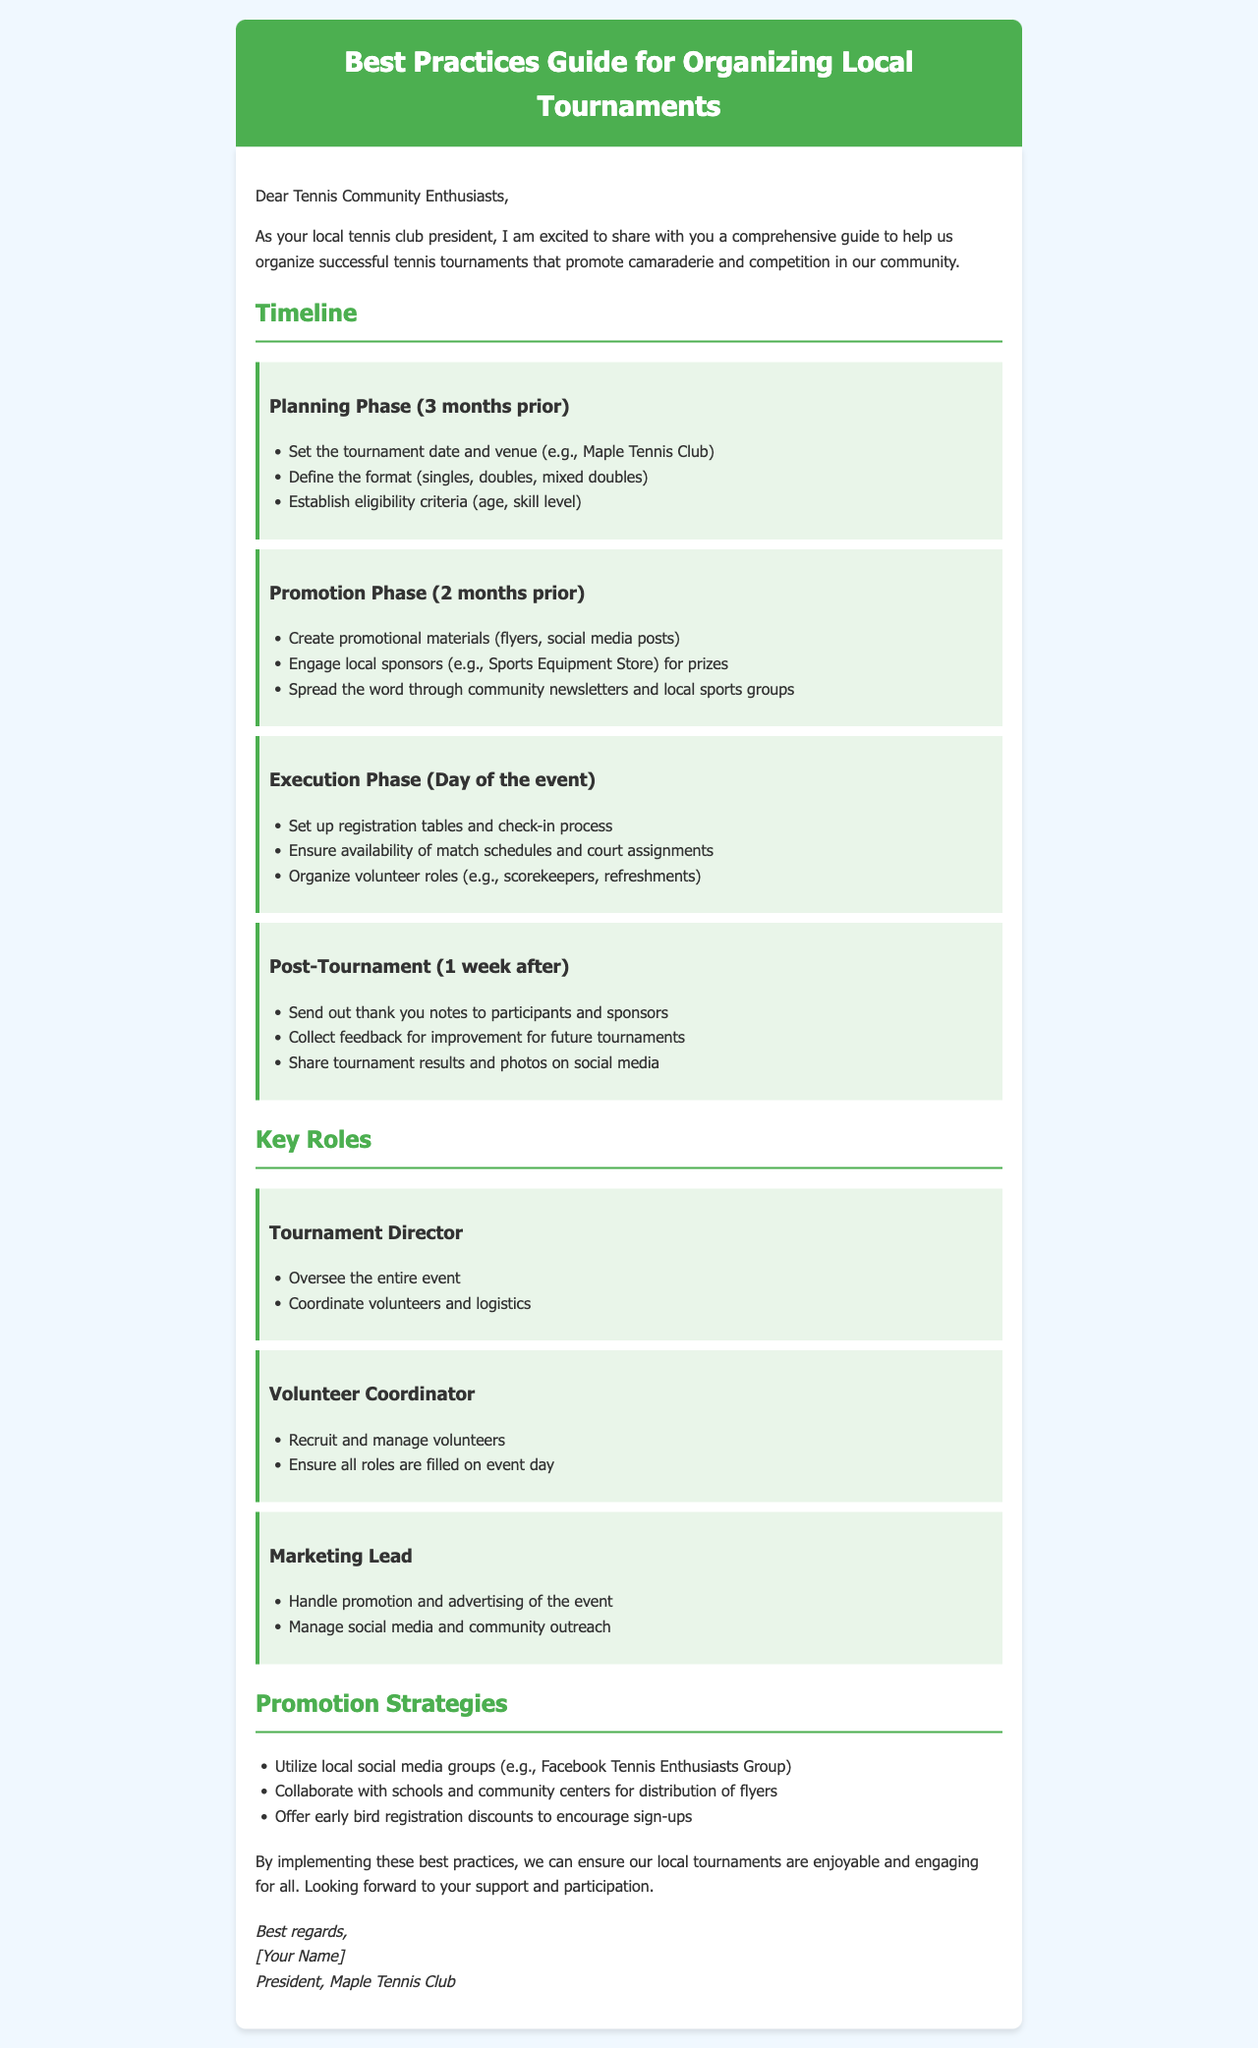What is the planning phase time frame? The planning phase occurs three months prior to the tournament.
Answer: 3 months prior What is one key role of the Marketing Lead? The Marketing Lead is responsible for handling promotion and advertising of the event.
Answer: Handle promotion What is one promotion strategy mentioned? A promotion strategy mentioned is to collaborate with schools and community centers for distribution of flyers.
Answer: Collaborate with schools How many weeks after the tournament should feedback be collected? Feedback should be collected one week after the tournament.
Answer: 1 week after What does the Tournament Director oversee? The Tournament Director oversees the entire event.
Answer: Entire event What is the eligibility criterion mentioned for participants? The eligibility criteria include age and skill level.
Answer: Age, skill level What is the venue example provided in the document? The venue example provided is Maple Tennis Club.
Answer: Maple Tennis Club What is the primary goal of the guide? The primary goal of the guide is to help organize successful tennis tournaments.
Answer: Organize successful tournaments What type of tournaments can be defined? The defined tournament formats include singles, doubles, and mixed doubles.
Answer: Singles, doubles, mixed doubles 